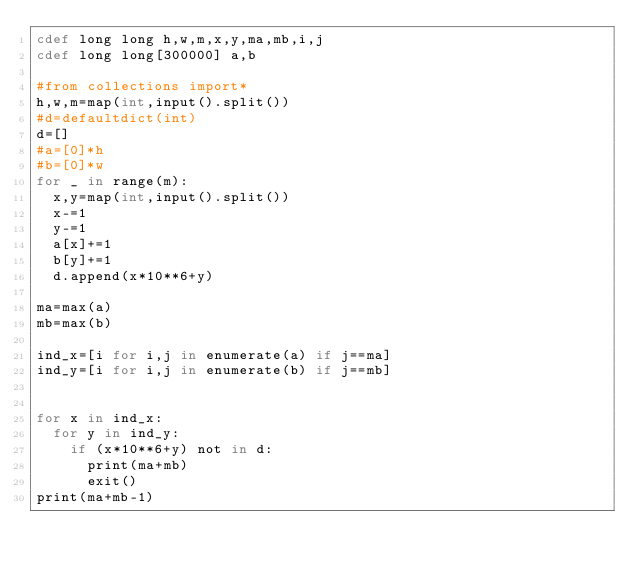Convert code to text. <code><loc_0><loc_0><loc_500><loc_500><_Cython_>cdef long long h,w,m,x,y,ma,mb,i,j
cdef long long[300000] a,b

#from collections import*
h,w,m=map(int,input().split())
#d=defaultdict(int)
d=[]
#a=[0]*h
#b=[0]*w
for _ in range(m):
  x,y=map(int,input().split())
  x-=1
  y-=1
  a[x]+=1
  b[y]+=1
  d.append(x*10**6+y)

ma=max(a)
mb=max(b)

ind_x=[i for i,j in enumerate(a) if j==ma]
ind_y=[i for i,j in enumerate(b) if j==mb]


for x in ind_x:
  for y in ind_y:
    if (x*10**6+y) not in d:
      print(ma+mb)
      exit()
print(ma+mb-1)
</code> 